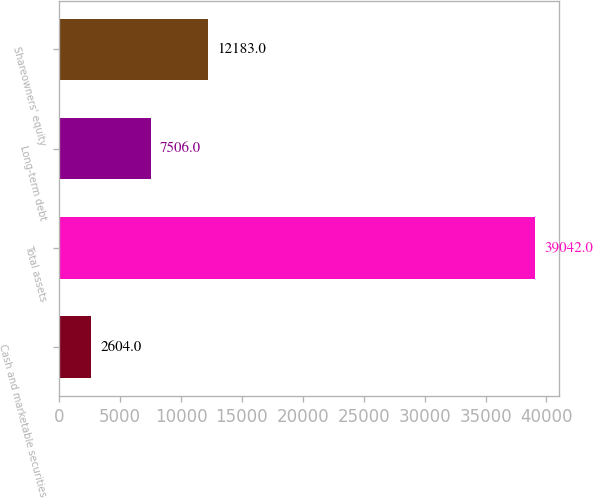Convert chart. <chart><loc_0><loc_0><loc_500><loc_500><bar_chart><fcel>Cash and marketable securities<fcel>Total assets<fcel>Long-term debt<fcel>Shareowners' equity<nl><fcel>2604<fcel>39042<fcel>7506<fcel>12183<nl></chart> 